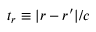Convert formula to latex. <formula><loc_0><loc_0><loc_500><loc_500>t _ { r } \equiv | r - r ^ { \prime } | / c</formula> 